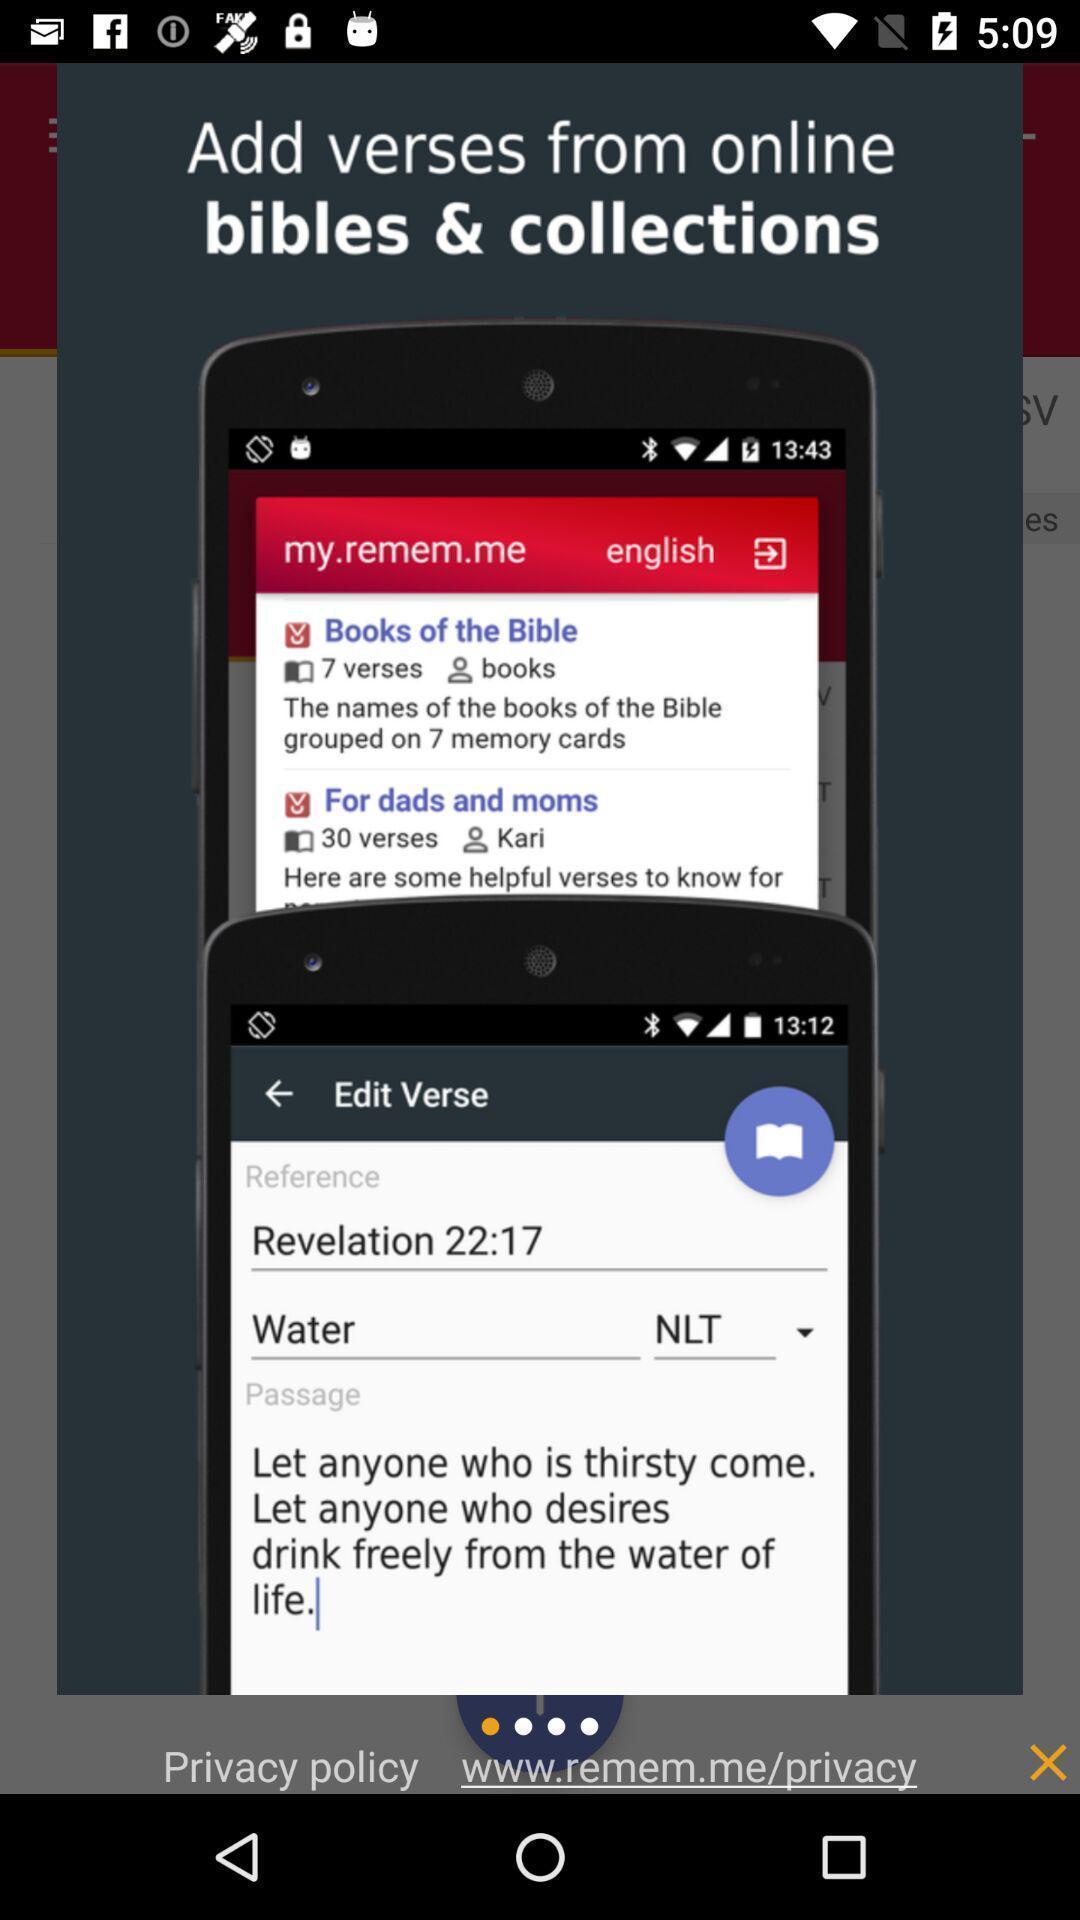Explain what's happening in this screen capture. Screen page of a bible app. 